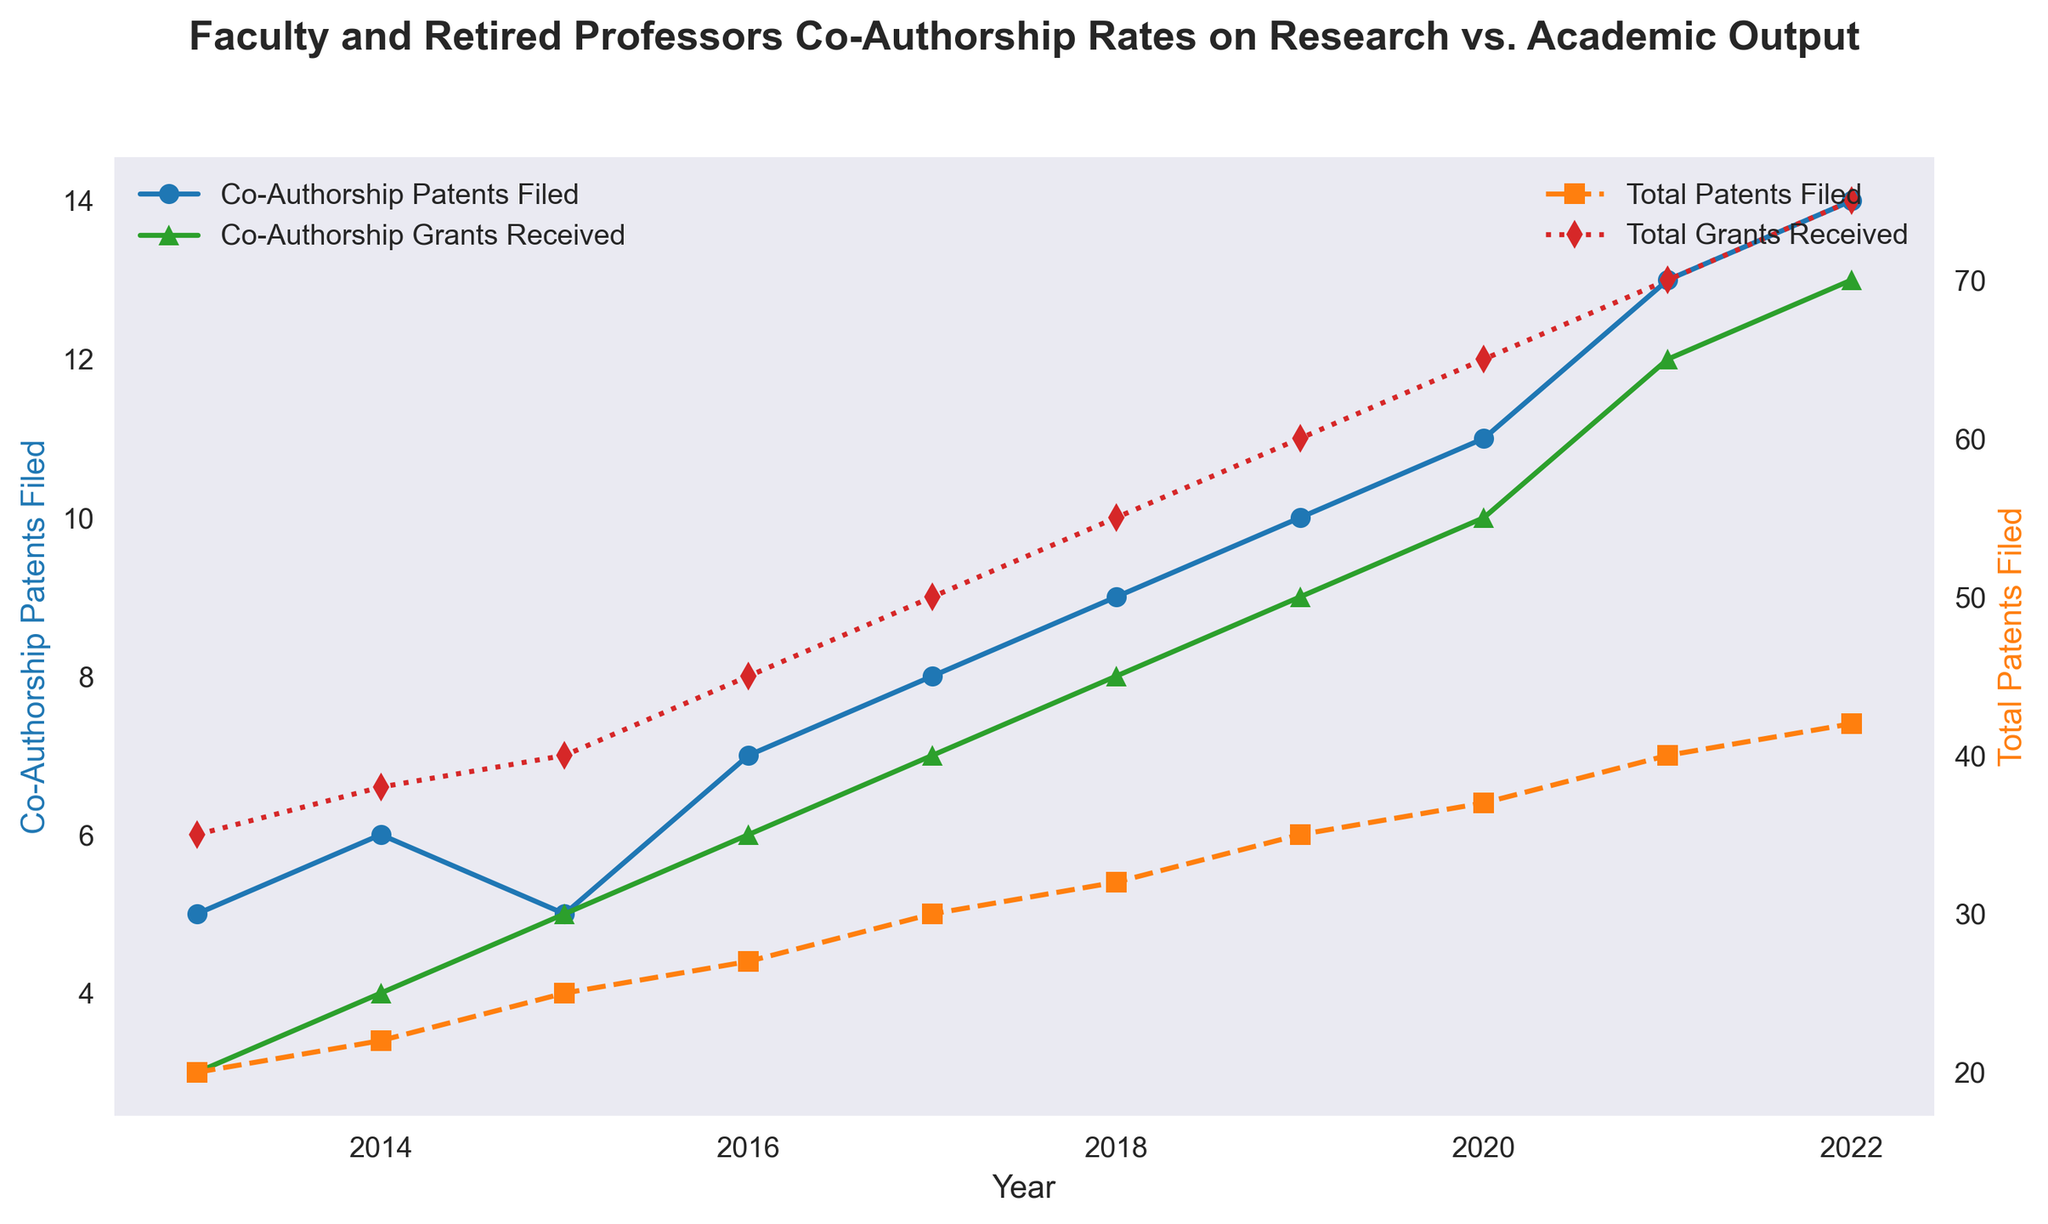What trend can be observed about the co-authorship patents filed over the years? By examining the blue line representing 'Co-Authorship Patents Filed', it is clear that there is a consistent upward trend from 2013 (5 patents) to 2022 (14 patents). Each year shows either an increase or a steady number of patents filed.
Answer: Increasing trend In what year did co-authorship research grants received reach 10? The green line ‘Co-Authorship Grants Received’ shows markers indicating the received grants each year. The year when grants reached 10 is visible at the marker corresponding to year 2020.
Answer: 2020 Which year experienced the highest total research grants received, and what is the number? The red line with markers indicates the ‘Total Research Grants Received’. The highest number of grants received, which is marked in 2022, is 75.
Answer: 2022, 75 Was there a year where the number of co-authorship patents filed was equal to the number of co-authorship research grants received? By comparison of the blue and green lines, there are no points where the number of co-authorship patents filed equals the number of co-authorship research grants for any year.
Answer: No How does the growth rate of total patents filed compare to that of total research grants received from 2013 to 2022? From the orange and red lines, the total patents filed increased by 22 (from 20 to 42), and total research grants received increased by 40 (from 35 to 75). The growth rate of research grants received is higher compared to patents filed.
Answer: Research grants received grew faster In which years did the number of co-authorship patents filed and co-authorship research grants received increase by the same margin compared to the previous year? Inspecting the blue and green lines’ growth each year, both increased from 2017 to 2018 by 1 (8 to 9 for patents and 7 to 8 for grants) and from 2018 to 2019 (9 to 10 for patents and 8 to 9 for grants).
Answer: 2017 to 2018, 2018 to 2019 What is the difference in total patents filed between 2022 and 2017? Between 2017 (30) and 2022 (42), the total patents filed difference is calculated as 42-30.
Answer: 12 Describe the change in co-authorship patents filed from 2014 to 2015. The blue line shows a decrease in co-authorship patents filed from 6 in 2014 to 5 in 2015.
Answer: Decrease What is the average number of research grants received per year between 2013 and 2022? Summing up the values for research grants received each year (35+38+40+45+50+55+60+65+70+75) and dividing by the number of years (10) results in the average.
Answer: 53 Which color represents the total patents filed in the plot? The total patents filed are depicted by the orange line with square markers.
Answer: Orange 